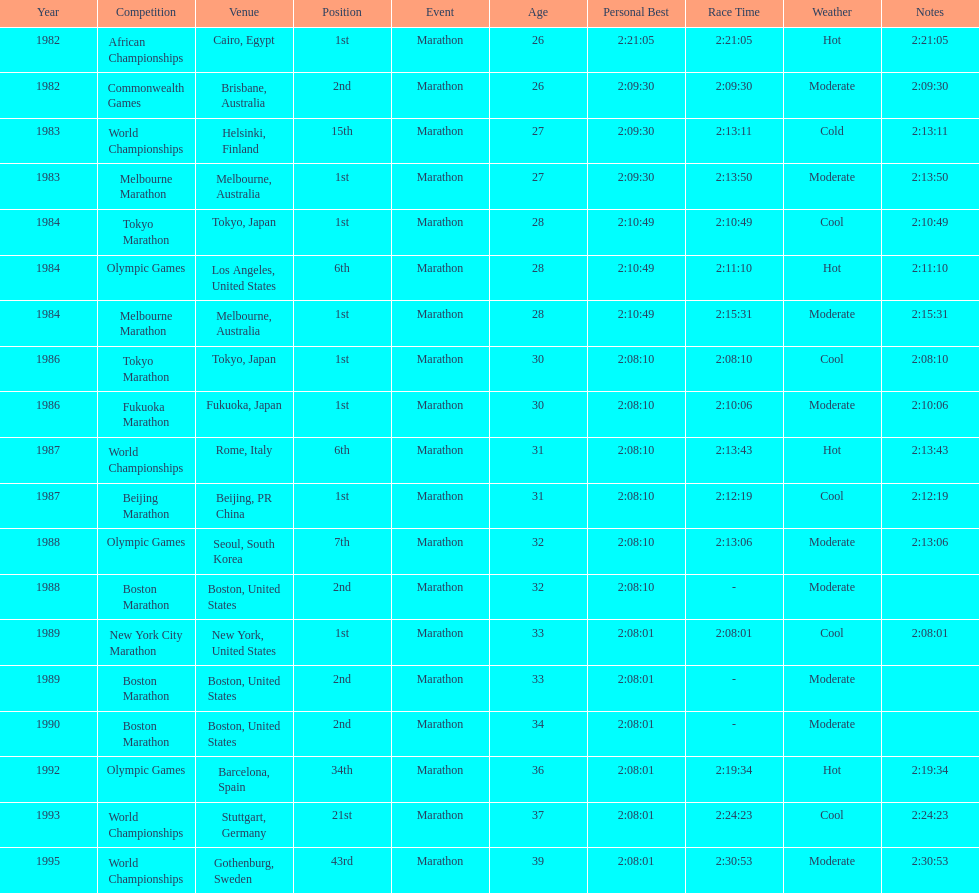What was the first marathon juma ikangaa won? 1982 African Championships. 